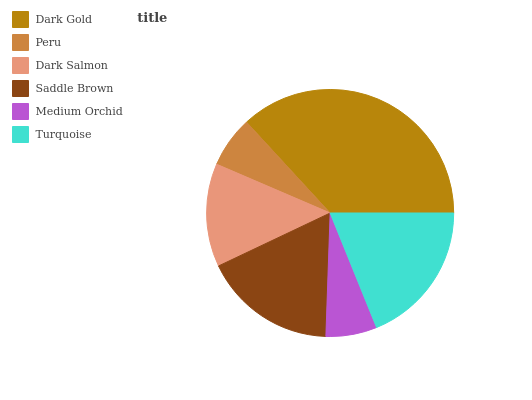Is Medium Orchid the minimum?
Answer yes or no. Yes. Is Dark Gold the maximum?
Answer yes or no. Yes. Is Peru the minimum?
Answer yes or no. No. Is Peru the maximum?
Answer yes or no. No. Is Dark Gold greater than Peru?
Answer yes or no. Yes. Is Peru less than Dark Gold?
Answer yes or no. Yes. Is Peru greater than Dark Gold?
Answer yes or no. No. Is Dark Gold less than Peru?
Answer yes or no. No. Is Saddle Brown the high median?
Answer yes or no. Yes. Is Dark Salmon the low median?
Answer yes or no. Yes. Is Peru the high median?
Answer yes or no. No. Is Medium Orchid the low median?
Answer yes or no. No. 